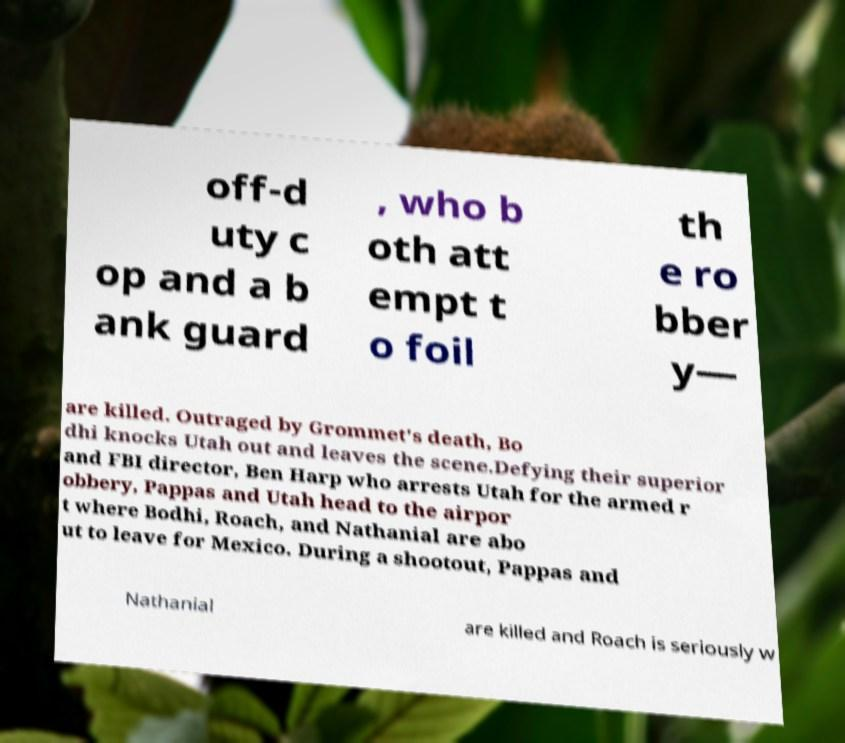Could you extract and type out the text from this image? off-d uty c op and a b ank guard , who b oth att empt t o foil th e ro bber y— are killed. Outraged by Grommet's death, Bo dhi knocks Utah out and leaves the scene.Defying their superior and FBI director, Ben Harp who arrests Utah for the armed r obbery, Pappas and Utah head to the airpor t where Bodhi, Roach, and Nathanial are abo ut to leave for Mexico. During a shootout, Pappas and Nathanial are killed and Roach is seriously w 